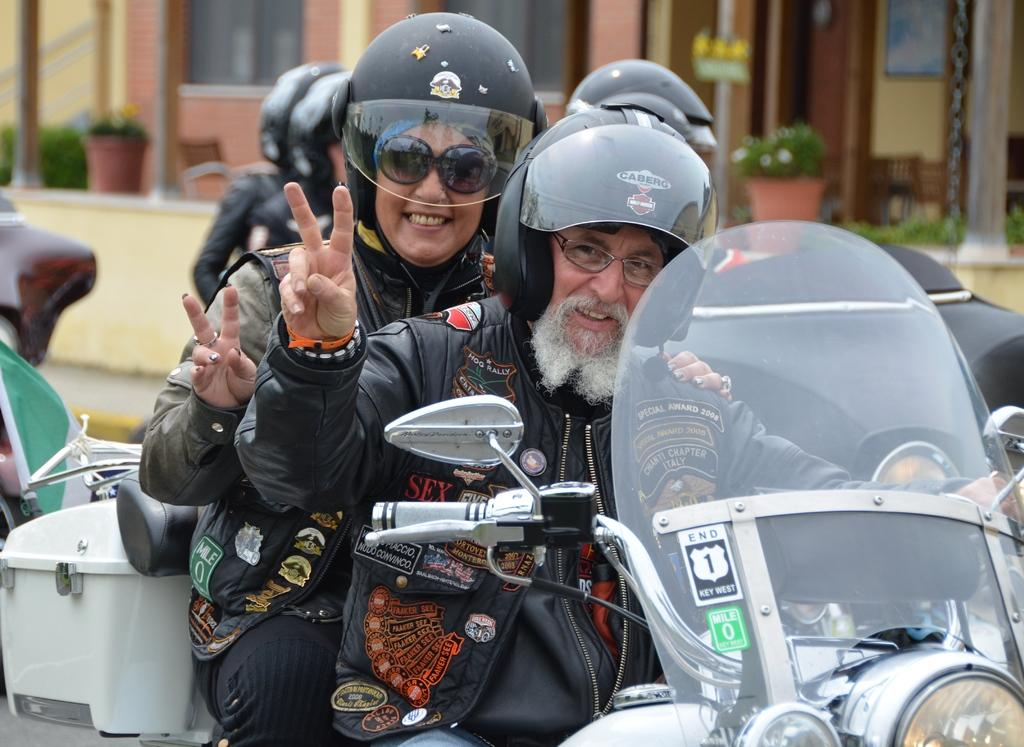How many people are in the image? There are people in the image. What are two people in the image doing? Two people in the image are riding a bike. What safety precautions are the people taking while riding the bike? The people riding the bike are wearing helmets. What expression do the people riding the bike have? The people riding the bike are smiling. What type of bait is being used by the horses in the image? There are no horses present in the image, and therefore no bait is being used. 